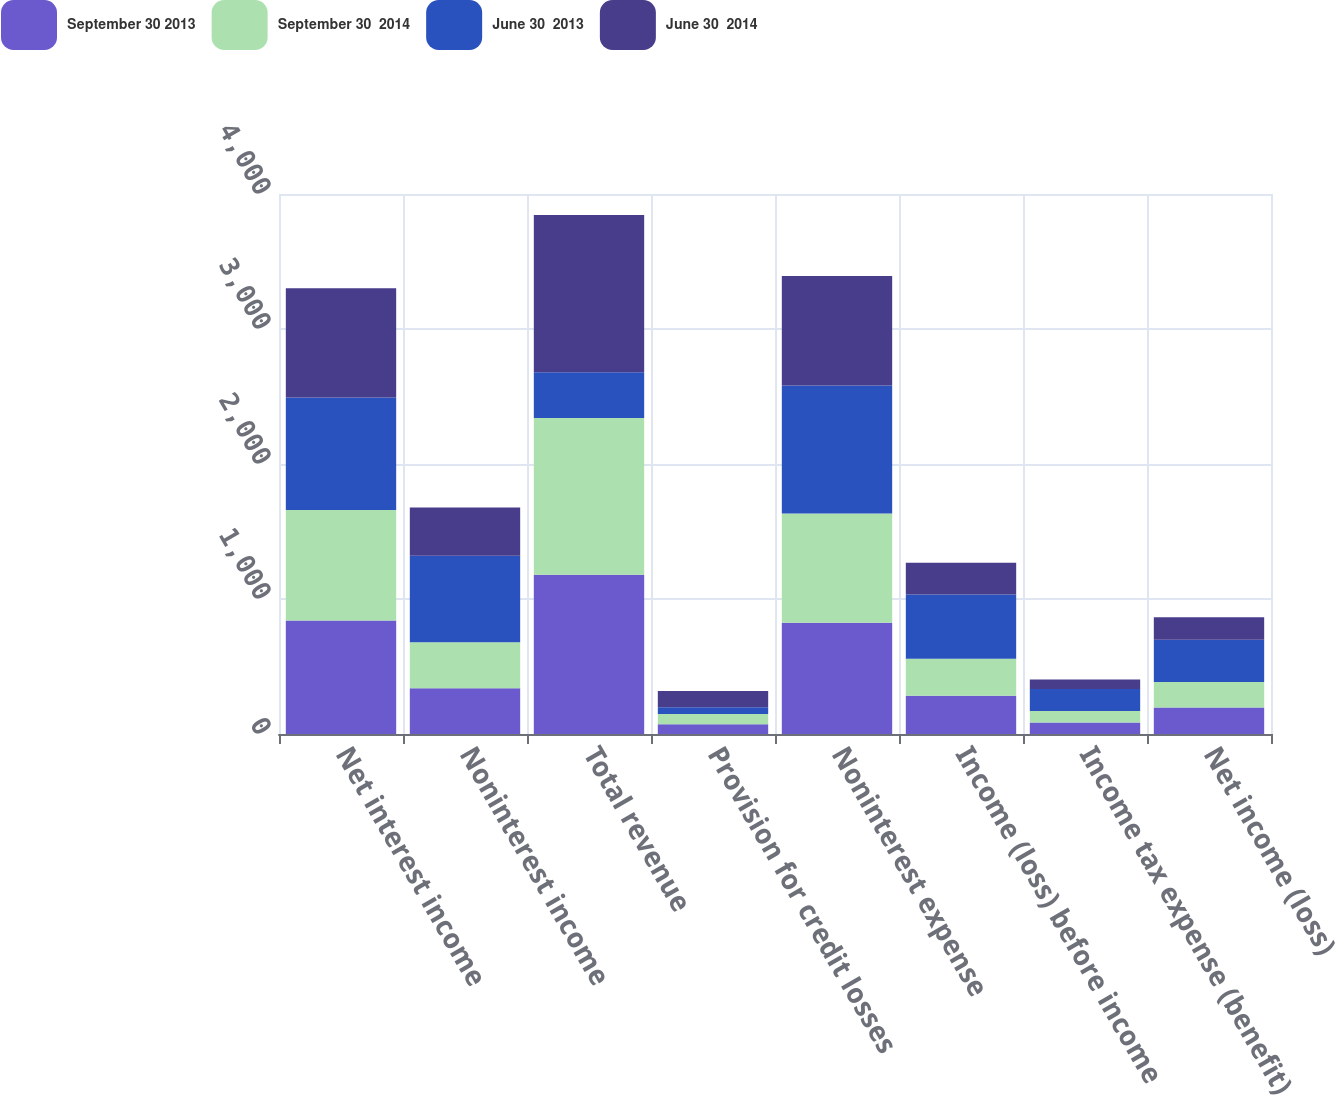Convert chart. <chart><loc_0><loc_0><loc_500><loc_500><stacked_bar_chart><ecel><fcel>Net interest income<fcel>Noninterest income<fcel>Total revenue<fcel>Provision for credit losses<fcel>Noninterest expense<fcel>Income (loss) before income<fcel>Income tax expense (benefit)<fcel>Net income (loss)<nl><fcel>September 30 2013<fcel>840<fcel>339<fcel>1179<fcel>72<fcel>824<fcel>283<fcel>86<fcel>197<nl><fcel>September 30  2014<fcel>820<fcel>341<fcel>1161<fcel>77<fcel>810<fcel>274<fcel>85<fcel>189<nl><fcel>June 30  2013<fcel>833<fcel>640<fcel>339<fcel>49<fcel>948<fcel>476<fcel>163<fcel>313<nl><fcel>June 30  2014<fcel>808<fcel>358<fcel>1166<fcel>121<fcel>810<fcel>235<fcel>69<fcel>166<nl></chart> 